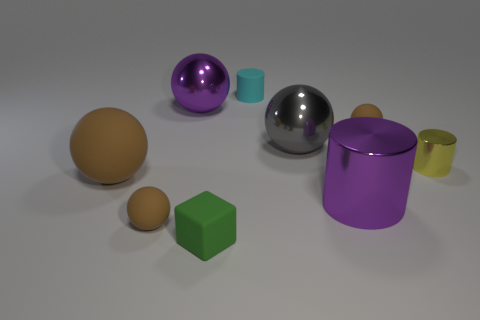There is a metal object that is in front of the tiny yellow cylinder; what color is it?
Offer a very short reply. Purple. What number of cylinders are small matte things or metal things?
Make the answer very short. 3. There is a brown matte ball that is to the right of the shiny object behind the gray metal object; how big is it?
Keep it short and to the point. Small. There is a small shiny object; does it have the same color as the rubber ball behind the small yellow shiny object?
Keep it short and to the point. No. There is a small yellow metal thing; how many tiny shiny things are on the right side of it?
Your answer should be very brief. 0. Is the number of green shiny cubes less than the number of brown things?
Your answer should be very brief. Yes. What size is the thing that is behind the yellow cylinder and left of the block?
Offer a very short reply. Large. Is the color of the small sphere that is on the right side of the small green object the same as the big rubber ball?
Keep it short and to the point. Yes. Is the number of tiny cyan objects that are behind the tiny cyan cylinder less than the number of tiny spheres?
Your answer should be very brief. Yes. What shape is the small green object that is made of the same material as the tiny cyan thing?
Make the answer very short. Cube. 